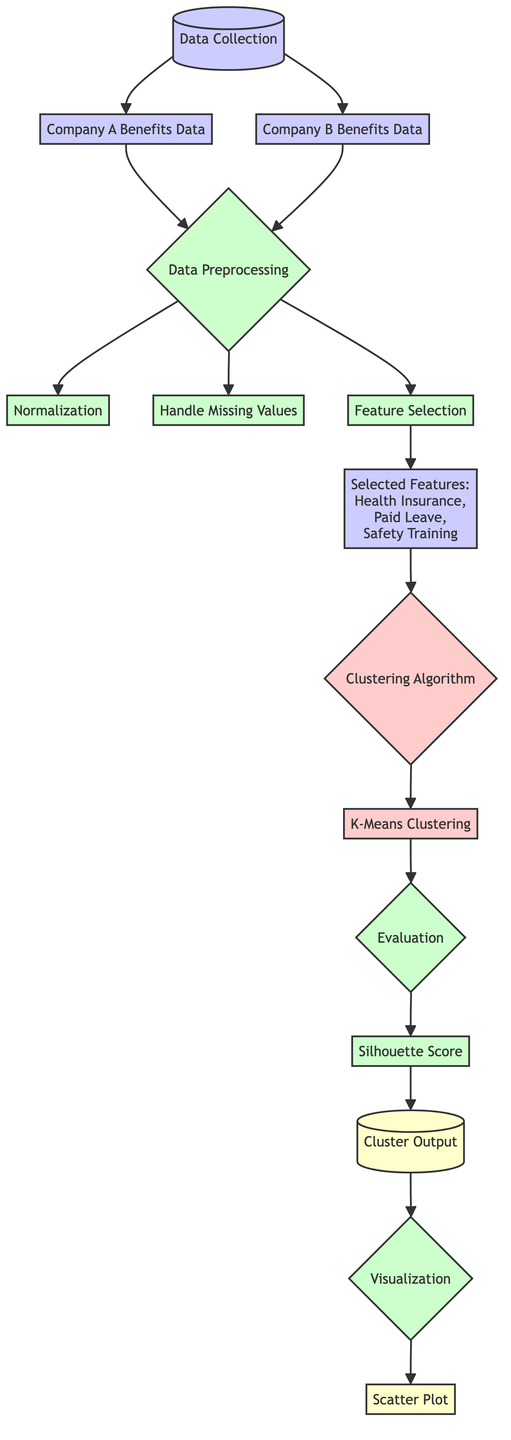What is the first node in the diagram? The first node is labeled "Data Collection," indicating the starting point of the process where data is gathered from the construction companies.
Answer: Data Collection How many companies' data are included in the diagram? The diagram shows data from two companies, Company A and Company B, as separate nodes representing their benefits data.
Answer: Two What is the purpose of the "Data Preprocessing" node? The "Data Preprocessing" node serves as a necessary step to prepare the collected data for analysis, ensuring it's in a suitable format for clustering.
Answer: Prepare data What follows after "Normalization" in the diagram? After "Normalization," the next step is "Handle Missing Values," indicating that ensuring data completeness is essential before feature selection.
Answer: Handle Missing Values Which features are selected for clustering? The features selected for clustering, as displayed in the node, are "Health Insurance," "Paid Leave," and "Safety Training."
Answer: Health Insurance, Paid Leave, Safety Training What clustering algorithm is used in this diagram? The diagram indicates "K-Means Clustering" as the specific clustering algorithm applied to the processed data.
Answer: K-Means Clustering Which process follows "Silhouette Score?" After the "Silhouette Score," the flow continues to the "Cluster Output," demonstrating the evaluation's outcome concerning the clustering quality.
Answer: Cluster Output What type of output is generated from the "Visualization" node? The visualization node produces a "Scatter Plot," which helps visually represent the clusters formed from the data analysis.
Answer: Scatter Plot How many main processes are present in the diagram? The diagram includes four main processes: "Data Preprocessing," "Clustering Algorithm," "Evaluation," and "Visualization."
Answer: Four 